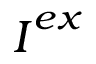Convert formula to latex. <formula><loc_0><loc_0><loc_500><loc_500>I ^ { e x }</formula> 